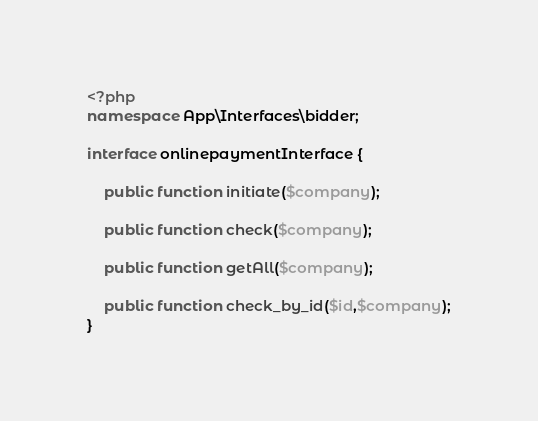Convert code to text. <code><loc_0><loc_0><loc_500><loc_500><_PHP_><?php
namespace App\Interfaces\bidder;

interface onlinepaymentInterface {

    public function initiate($company);

    public function check($company);

    public function getAll($company);

    public function check_by_id($id,$company);
}</code> 